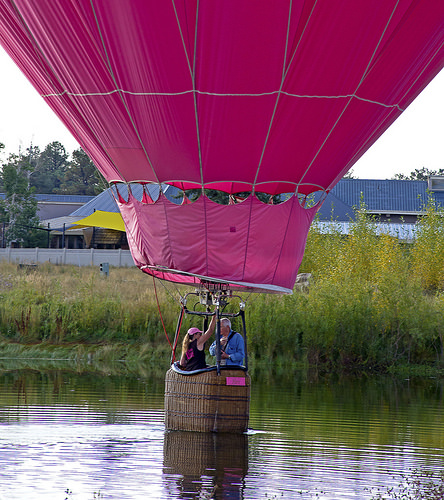<image>
Can you confirm if the balloon is next to the water? No. The balloon is not positioned next to the water. They are located in different areas of the scene. Is the basket above the water? Yes. The basket is positioned above the water in the vertical space, higher up in the scene. Where is the baloon in relation to the water? Is it above the water? Yes. The baloon is positioned above the water in the vertical space, higher up in the scene. 